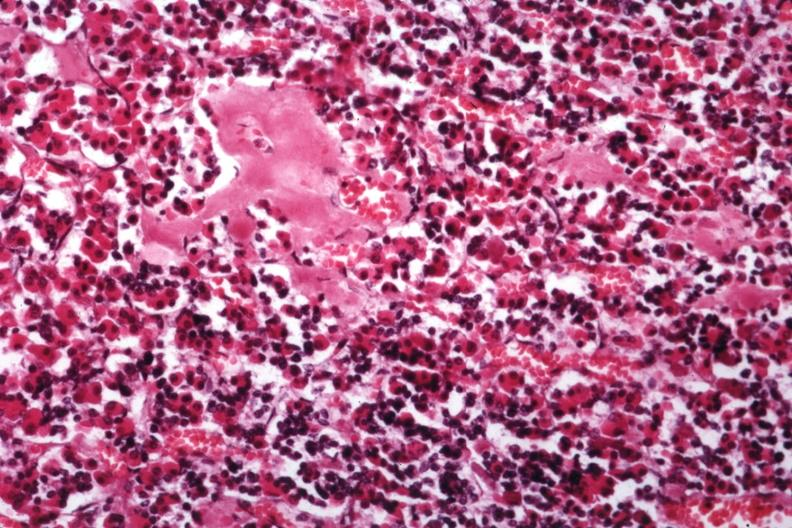what is hyalin mass in pituitary which is amyloid there are several slides from this case in this file 23 yowf amyloid limited to brain had?
Answer the question using a single word or phrase. Incontinence headaches and failure maintain weight very strange not angiopathy r. endocrine present 